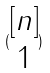Convert formula to latex. <formula><loc_0><loc_0><loc_500><loc_500>( \begin{matrix} [ n ] \\ 1 \end{matrix} )</formula> 